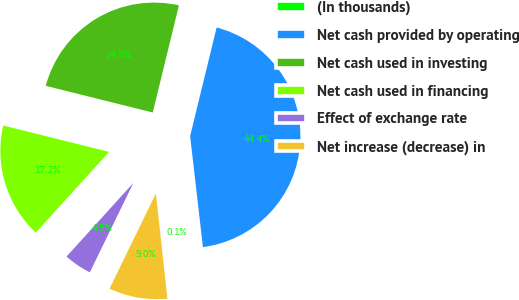Convert chart to OTSL. <chart><loc_0><loc_0><loc_500><loc_500><pie_chart><fcel>(In thousands)<fcel>Net cash provided by operating<fcel>Net cash used in investing<fcel>Net cash used in financing<fcel>Effect of exchange rate<fcel>Net increase (decrease) in<nl><fcel>0.09%<fcel>44.36%<fcel>24.92%<fcel>17.15%<fcel>4.52%<fcel>8.95%<nl></chart> 